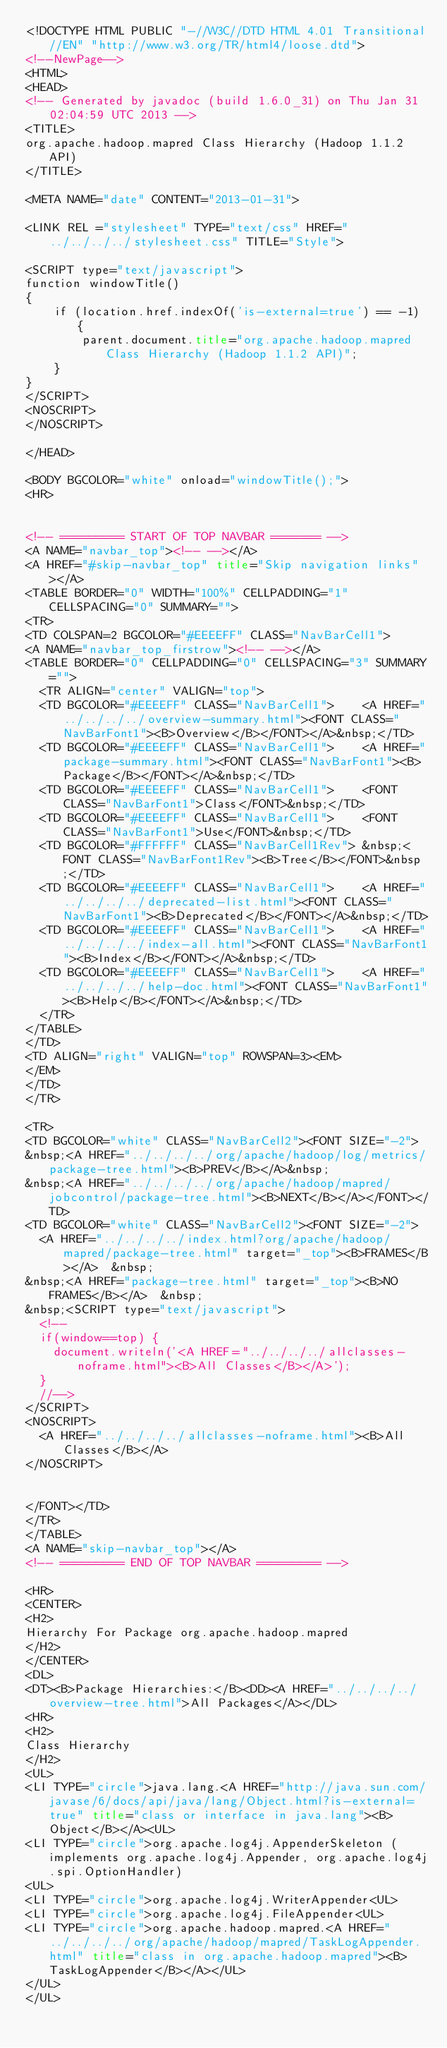<code> <loc_0><loc_0><loc_500><loc_500><_HTML_><!DOCTYPE HTML PUBLIC "-//W3C//DTD HTML 4.01 Transitional//EN" "http://www.w3.org/TR/html4/loose.dtd">
<!--NewPage-->
<HTML>
<HEAD>
<!-- Generated by javadoc (build 1.6.0_31) on Thu Jan 31 02:04:59 UTC 2013 -->
<TITLE>
org.apache.hadoop.mapred Class Hierarchy (Hadoop 1.1.2 API)
</TITLE>

<META NAME="date" CONTENT="2013-01-31">

<LINK REL ="stylesheet" TYPE="text/css" HREF="../../../../stylesheet.css" TITLE="Style">

<SCRIPT type="text/javascript">
function windowTitle()
{
    if (location.href.indexOf('is-external=true') == -1) {
        parent.document.title="org.apache.hadoop.mapred Class Hierarchy (Hadoop 1.1.2 API)";
    }
}
</SCRIPT>
<NOSCRIPT>
</NOSCRIPT>

</HEAD>

<BODY BGCOLOR="white" onload="windowTitle();">
<HR>


<!-- ========= START OF TOP NAVBAR ======= -->
<A NAME="navbar_top"><!-- --></A>
<A HREF="#skip-navbar_top" title="Skip navigation links"></A>
<TABLE BORDER="0" WIDTH="100%" CELLPADDING="1" CELLSPACING="0" SUMMARY="">
<TR>
<TD COLSPAN=2 BGCOLOR="#EEEEFF" CLASS="NavBarCell1">
<A NAME="navbar_top_firstrow"><!-- --></A>
<TABLE BORDER="0" CELLPADDING="0" CELLSPACING="3" SUMMARY="">
  <TR ALIGN="center" VALIGN="top">
  <TD BGCOLOR="#EEEEFF" CLASS="NavBarCell1">    <A HREF="../../../../overview-summary.html"><FONT CLASS="NavBarFont1"><B>Overview</B></FONT></A>&nbsp;</TD>
  <TD BGCOLOR="#EEEEFF" CLASS="NavBarCell1">    <A HREF="package-summary.html"><FONT CLASS="NavBarFont1"><B>Package</B></FONT></A>&nbsp;</TD>
  <TD BGCOLOR="#EEEEFF" CLASS="NavBarCell1">    <FONT CLASS="NavBarFont1">Class</FONT>&nbsp;</TD>
  <TD BGCOLOR="#EEEEFF" CLASS="NavBarCell1">    <FONT CLASS="NavBarFont1">Use</FONT>&nbsp;</TD>
  <TD BGCOLOR="#FFFFFF" CLASS="NavBarCell1Rev"> &nbsp;<FONT CLASS="NavBarFont1Rev"><B>Tree</B></FONT>&nbsp;</TD>
  <TD BGCOLOR="#EEEEFF" CLASS="NavBarCell1">    <A HREF="../../../../deprecated-list.html"><FONT CLASS="NavBarFont1"><B>Deprecated</B></FONT></A>&nbsp;</TD>
  <TD BGCOLOR="#EEEEFF" CLASS="NavBarCell1">    <A HREF="../../../../index-all.html"><FONT CLASS="NavBarFont1"><B>Index</B></FONT></A>&nbsp;</TD>
  <TD BGCOLOR="#EEEEFF" CLASS="NavBarCell1">    <A HREF="../../../../help-doc.html"><FONT CLASS="NavBarFont1"><B>Help</B></FONT></A>&nbsp;</TD>
  </TR>
</TABLE>
</TD>
<TD ALIGN="right" VALIGN="top" ROWSPAN=3><EM>
</EM>
</TD>
</TR>

<TR>
<TD BGCOLOR="white" CLASS="NavBarCell2"><FONT SIZE="-2">
&nbsp;<A HREF="../../../../org/apache/hadoop/log/metrics/package-tree.html"><B>PREV</B></A>&nbsp;
&nbsp;<A HREF="../../../../org/apache/hadoop/mapred/jobcontrol/package-tree.html"><B>NEXT</B></A></FONT></TD>
<TD BGCOLOR="white" CLASS="NavBarCell2"><FONT SIZE="-2">
  <A HREF="../../../../index.html?org/apache/hadoop/mapred/package-tree.html" target="_top"><B>FRAMES</B></A>  &nbsp;
&nbsp;<A HREF="package-tree.html" target="_top"><B>NO FRAMES</B></A>  &nbsp;
&nbsp;<SCRIPT type="text/javascript">
  <!--
  if(window==top) {
    document.writeln('<A HREF="../../../../allclasses-noframe.html"><B>All Classes</B></A>');
  }
  //-->
</SCRIPT>
<NOSCRIPT>
  <A HREF="../../../../allclasses-noframe.html"><B>All Classes</B></A>
</NOSCRIPT>


</FONT></TD>
</TR>
</TABLE>
<A NAME="skip-navbar_top"></A>
<!-- ========= END OF TOP NAVBAR ========= -->

<HR>
<CENTER>
<H2>
Hierarchy For Package org.apache.hadoop.mapred
</H2>
</CENTER>
<DL>
<DT><B>Package Hierarchies:</B><DD><A HREF="../../../../overview-tree.html">All Packages</A></DL>
<HR>
<H2>
Class Hierarchy
</H2>
<UL>
<LI TYPE="circle">java.lang.<A HREF="http://java.sun.com/javase/6/docs/api/java/lang/Object.html?is-external=true" title="class or interface in java.lang"><B>Object</B></A><UL>
<LI TYPE="circle">org.apache.log4j.AppenderSkeleton (implements org.apache.log4j.Appender, org.apache.log4j.spi.OptionHandler)
<UL>
<LI TYPE="circle">org.apache.log4j.WriterAppender<UL>
<LI TYPE="circle">org.apache.log4j.FileAppender<UL>
<LI TYPE="circle">org.apache.hadoop.mapred.<A HREF="../../../../org/apache/hadoop/mapred/TaskLogAppender.html" title="class in org.apache.hadoop.mapred"><B>TaskLogAppender</B></A></UL>
</UL>
</UL></code> 